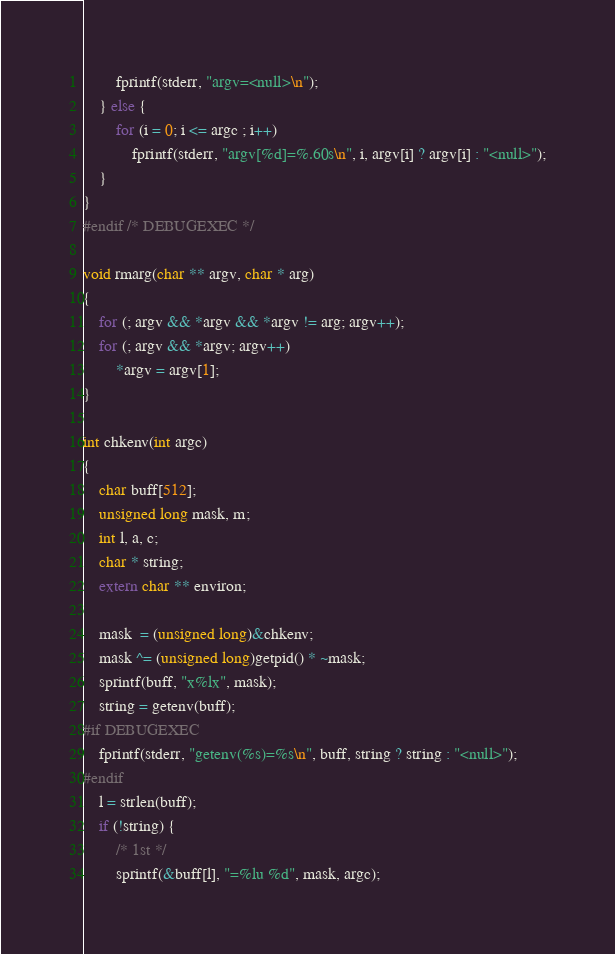Convert code to text. <code><loc_0><loc_0><loc_500><loc_500><_C_>		fprintf(stderr, "argv=<null>\n");
	} else { 
		for (i = 0; i <= argc ; i++)
			fprintf(stderr, "argv[%d]=%.60s\n", i, argv[i] ? argv[i] : "<null>");
	}
}
#endif /* DEBUGEXEC */

void rmarg(char ** argv, char * arg)
{
	for (; argv && *argv && *argv != arg; argv++);
	for (; argv && *argv; argv++)
		*argv = argv[1];
}

int chkenv(int argc)
{
	char buff[512];
	unsigned long mask, m;
	int l, a, c;
	char * string;
	extern char ** environ;

	mask  = (unsigned long)&chkenv;
	mask ^= (unsigned long)getpid() * ~mask;
	sprintf(buff, "x%lx", mask);
	string = getenv(buff);
#if DEBUGEXEC
	fprintf(stderr, "getenv(%s)=%s\n", buff, string ? string : "<null>");
#endif
	l = strlen(buff);
	if (!string) {
		/* 1st */
		sprintf(&buff[l], "=%lu %d", mask, argc);</code> 